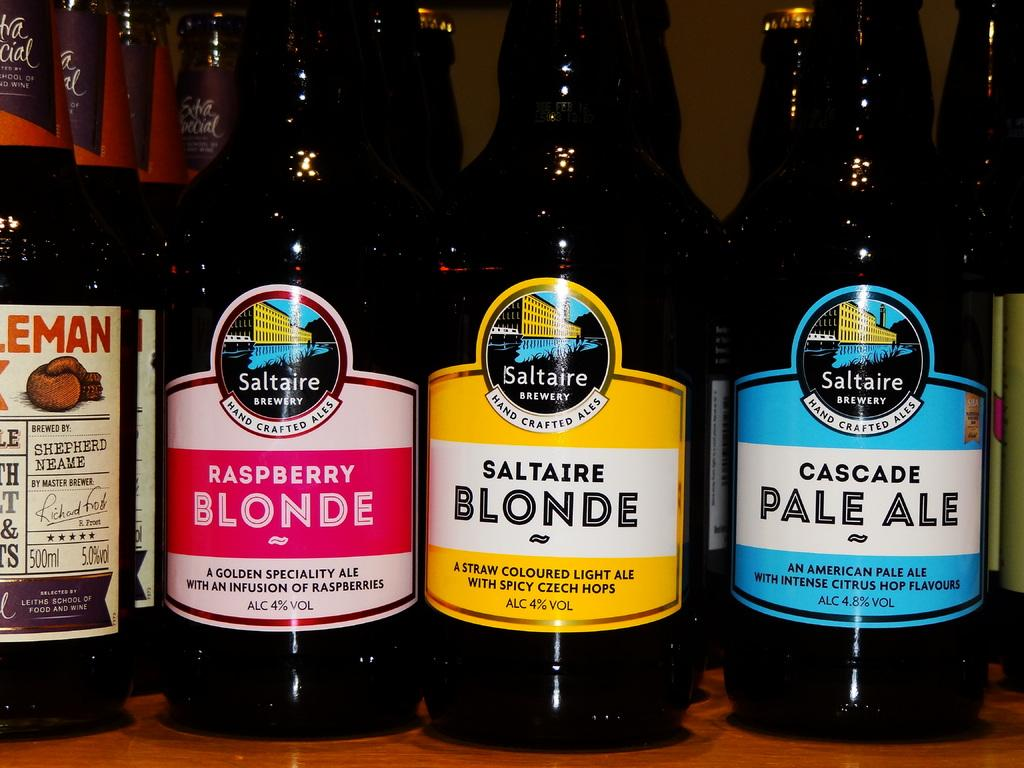<image>
Summarize the visual content of the image. A row of bottles of beers including raspberry ale and blonde ale. 